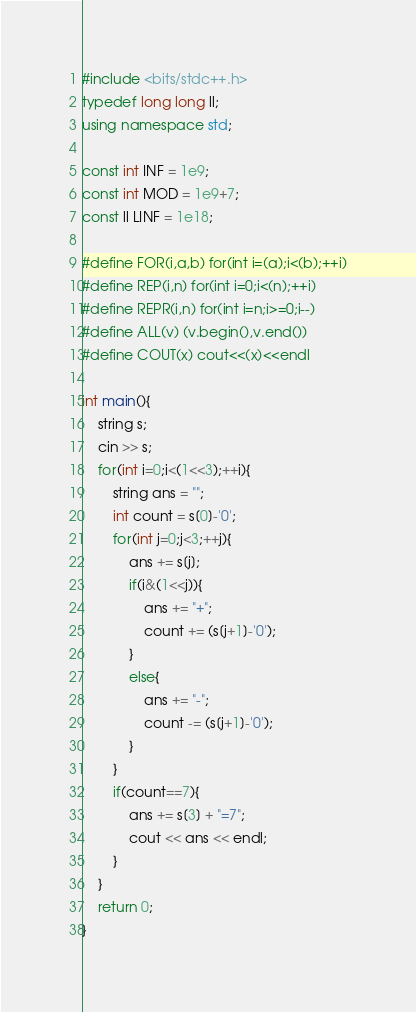<code> <loc_0><loc_0><loc_500><loc_500><_C++_>#include <bits/stdc++.h>
typedef long long ll;
using namespace std;

const int INF = 1e9;
const int MOD = 1e9+7;
const ll LINF = 1e18;

#define FOR(i,a,b) for(int i=(a);i<(b);++i)
#define REP(i,n) for(int i=0;i<(n);++i)
#define REPR(i,n) for(int i=n;i>=0;i--)
#define ALL(v) (v.begin(),v.end())
#define COUT(x) cout<<(x)<<endl

int main(){
    string s;
    cin >> s;
    for(int i=0;i<(1<<3);++i){
        string ans = "";
        int count = s[0]-'0';
        for(int j=0;j<3;++j){
            ans += s[j];
            if(i&(1<<j)){
                ans += "+";
                count += (s[j+1]-'0');
            }
            else{
                ans += "-";
                count -= (s[j+1]-'0');
            }
        }
        if(count==7){
            ans += s[3] + "=7";
            cout << ans << endl;
        }
    }
    return 0;
}  </code> 